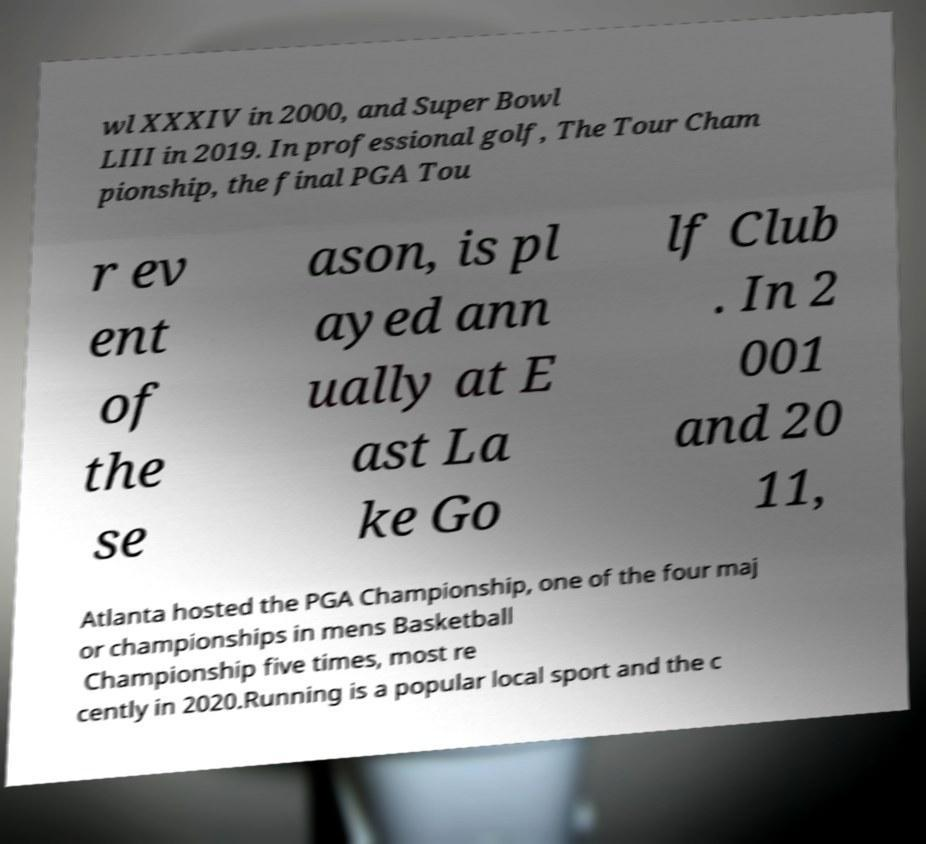I need the written content from this picture converted into text. Can you do that? wl XXXIV in 2000, and Super Bowl LIII in 2019. In professional golf, The Tour Cham pionship, the final PGA Tou r ev ent of the se ason, is pl ayed ann ually at E ast La ke Go lf Club . In 2 001 and 20 11, Atlanta hosted the PGA Championship, one of the four maj or championships in mens Basketball Championship five times, most re cently in 2020.Running is a popular local sport and the c 